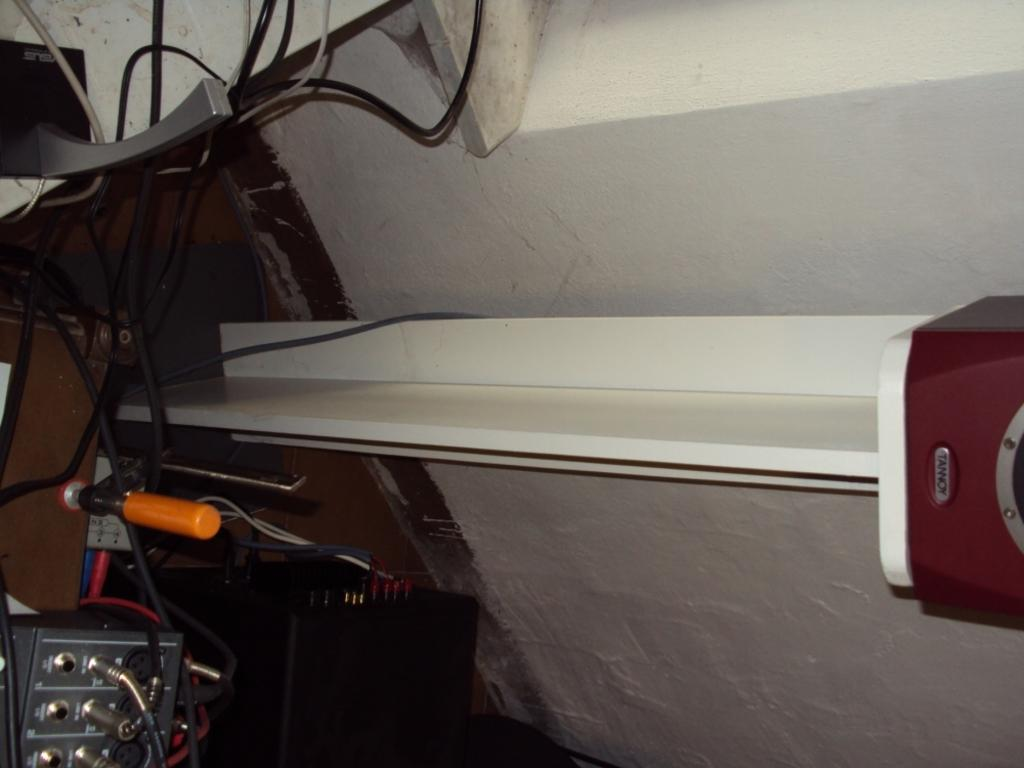What is located on the right side of the image? There is a machine on the right side of the image. What color is the wall next to the machine? The wall next to the machine is painted white. What can be seen on the left side of the image? There are cables and various electronic gadgets on the left side of the image. What type of decision does the yam make in the image? There is no yam present in the image, so it cannot make any decisions. 